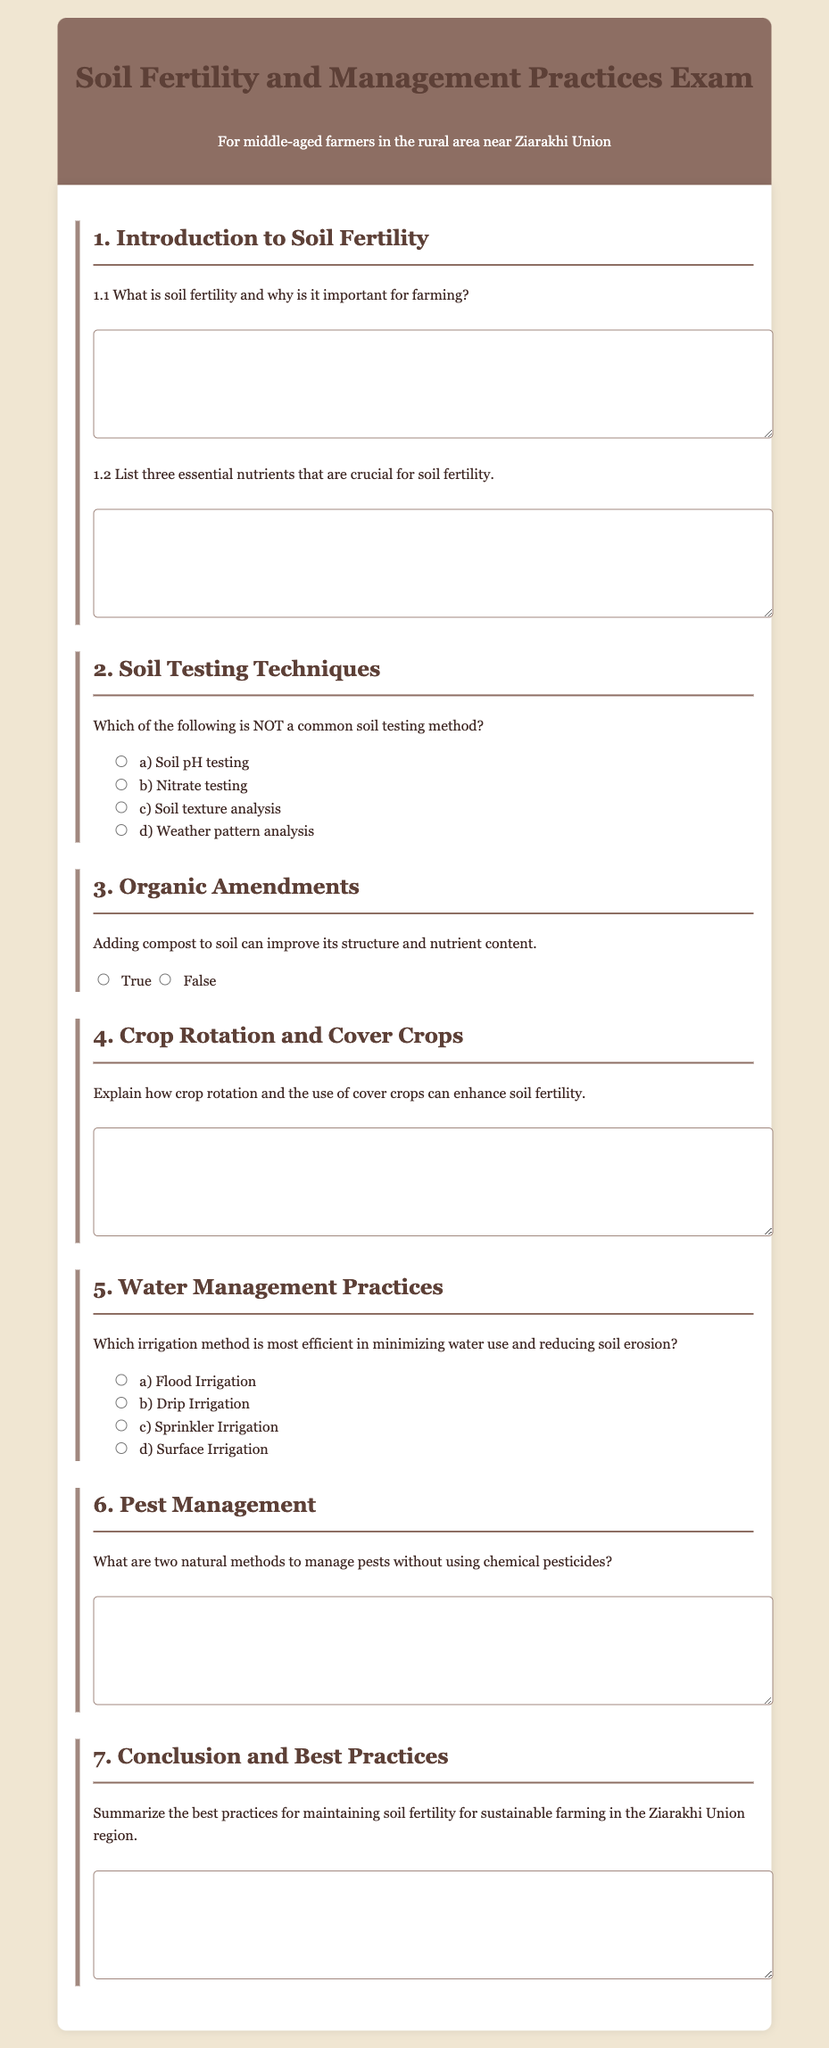What is soil fertility? Soil fertility is a measure of the soil's ability to provide essential nutrients to plants, which is crucial for farming success.
Answer: A measure of the soil's ability to provide essential nutrients List three essential nutrients for soil fertility. Essential nutrients crucial for soil fertility are typically nitrogen, phosphorus, and potassium.
Answer: Nitrogen, phosphorus, potassium Which irrigation method minimizes water use? Drip irrigation is the most efficient method for minimizing water use and reducing soil erosion.
Answer: Drip Irrigation What is the significance of compost in soil management? Compost improves soil structure and nutrient content, enhancing soil fertility.
Answer: Improves soil structure and nutrient content What are two natural pest management methods? Two natural methods to manage pests without chemicals include introducing beneficial insects and crop rotation.
Answer: Introducing beneficial insects, crop rotation 